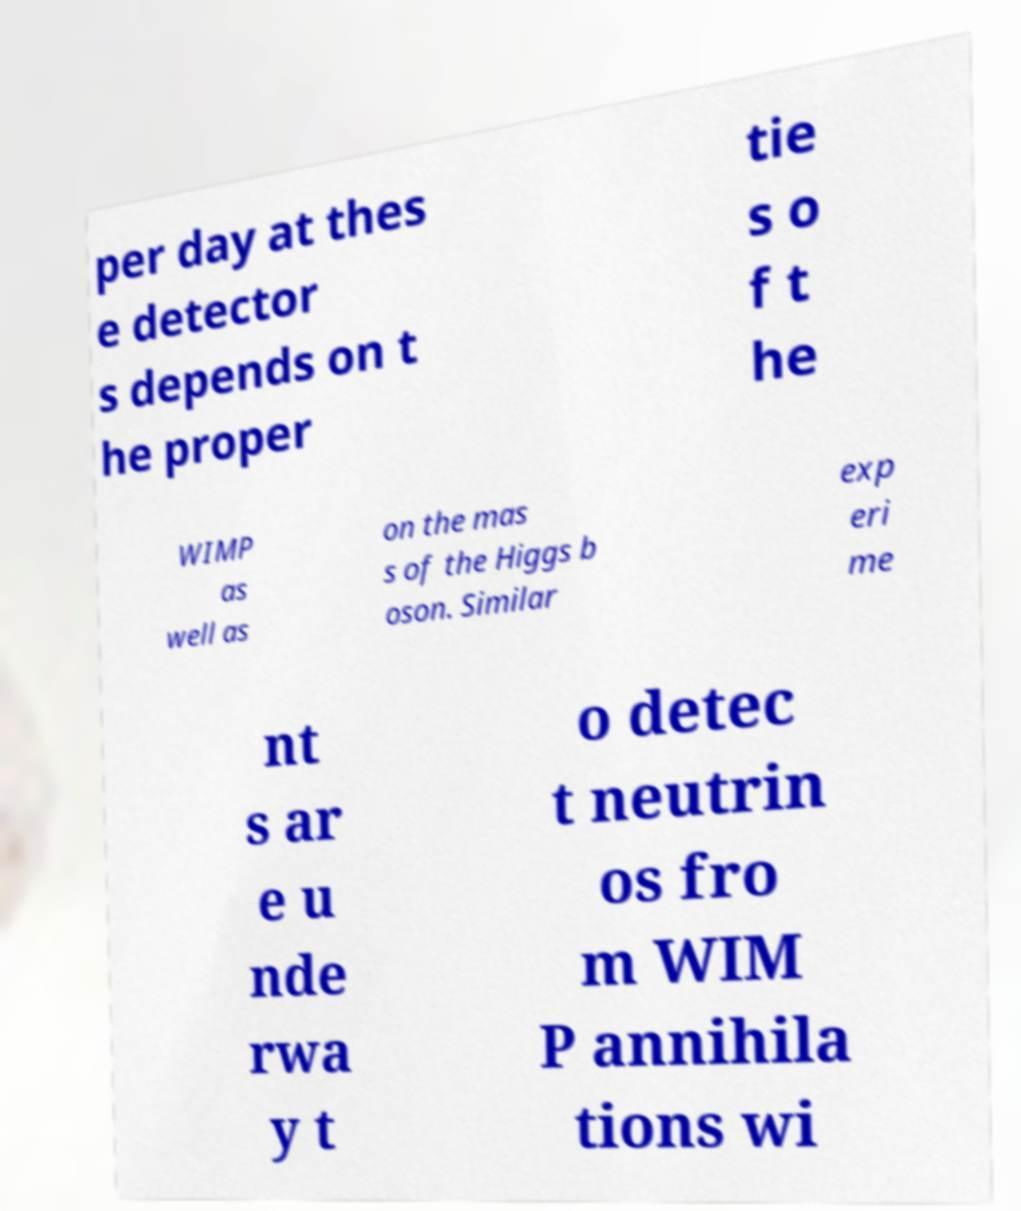What messages or text are displayed in this image? I need them in a readable, typed format. per day at thes e detector s depends on t he proper tie s o f t he WIMP as well as on the mas s of the Higgs b oson. Similar exp eri me nt s ar e u nde rwa y t o detec t neutrin os fro m WIM P annihila tions wi 